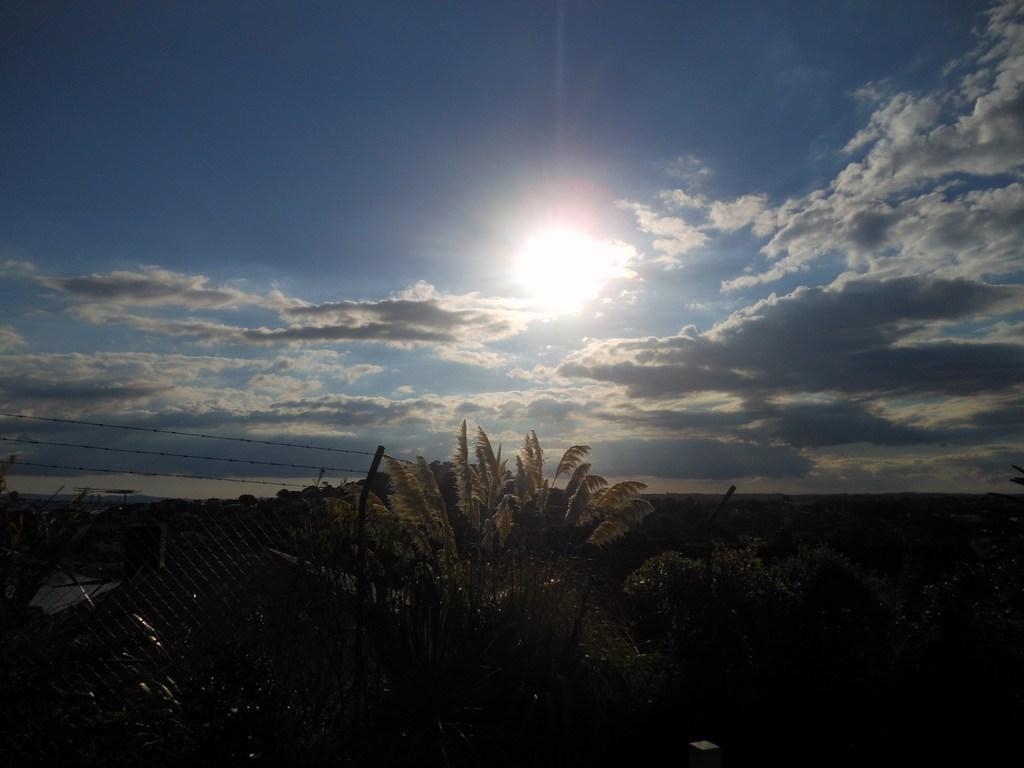What is located in the foreground of the image? There is a fence and a group of plants in the foreground of the image. What can be seen in the background of the image? The sky is visible in the background of the image. What is the condition of the sky in the image? The sky appears to be cloudy, and the sun is visible in the background. Where is the toothbrush located in the image? There is no toothbrush present in the image. What type of salt can be seen on the plants in the image? There is no salt visible on the plants in the image. 